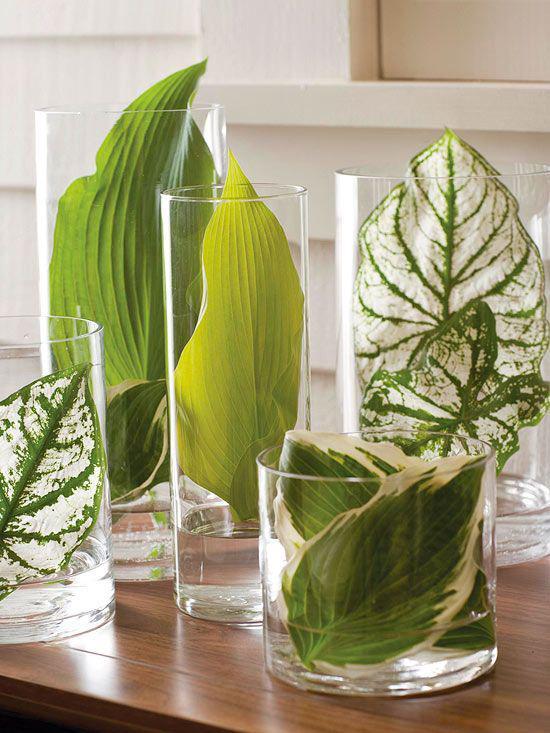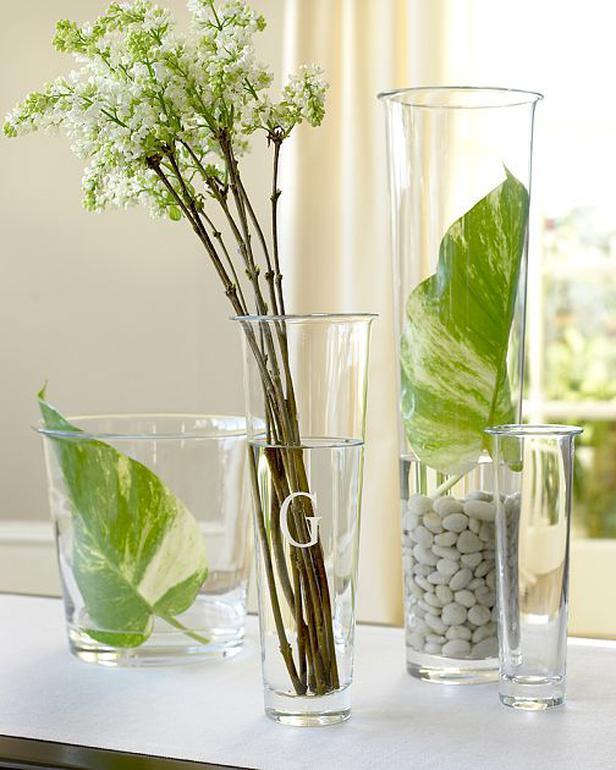The first image is the image on the left, the second image is the image on the right. Examine the images to the left and right. Is the description "The left and right image contains the same number of palm leaves." accurate? Answer yes or no. No. The first image is the image on the left, the second image is the image on the right. Given the left and right images, does the statement "The right image features a palm frond in a clear cylindrical vase flanked by objects with matching shapes." hold true? Answer yes or no. No. 